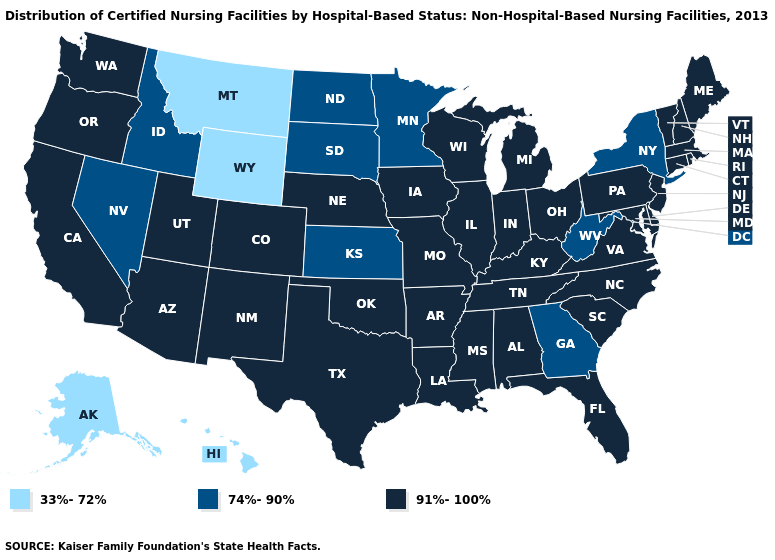Does Iowa have the highest value in the USA?
Be succinct. Yes. What is the lowest value in the Northeast?
Keep it brief. 74%-90%. What is the highest value in states that border Wisconsin?
Quick response, please. 91%-100%. Among the states that border Pennsylvania , which have the lowest value?
Answer briefly. New York, West Virginia. What is the value of New York?
Write a very short answer. 74%-90%. Among the states that border Montana , does Wyoming have the lowest value?
Keep it brief. Yes. Among the states that border Wisconsin , which have the lowest value?
Write a very short answer. Minnesota. Name the states that have a value in the range 91%-100%?
Write a very short answer. Alabama, Arizona, Arkansas, California, Colorado, Connecticut, Delaware, Florida, Illinois, Indiana, Iowa, Kentucky, Louisiana, Maine, Maryland, Massachusetts, Michigan, Mississippi, Missouri, Nebraska, New Hampshire, New Jersey, New Mexico, North Carolina, Ohio, Oklahoma, Oregon, Pennsylvania, Rhode Island, South Carolina, Tennessee, Texas, Utah, Vermont, Virginia, Washington, Wisconsin. Name the states that have a value in the range 74%-90%?
Quick response, please. Georgia, Idaho, Kansas, Minnesota, Nevada, New York, North Dakota, South Dakota, West Virginia. Which states have the highest value in the USA?
Give a very brief answer. Alabama, Arizona, Arkansas, California, Colorado, Connecticut, Delaware, Florida, Illinois, Indiana, Iowa, Kentucky, Louisiana, Maine, Maryland, Massachusetts, Michigan, Mississippi, Missouri, Nebraska, New Hampshire, New Jersey, New Mexico, North Carolina, Ohio, Oklahoma, Oregon, Pennsylvania, Rhode Island, South Carolina, Tennessee, Texas, Utah, Vermont, Virginia, Washington, Wisconsin. Does Montana have the lowest value in the USA?
Concise answer only. Yes. Name the states that have a value in the range 74%-90%?
Concise answer only. Georgia, Idaho, Kansas, Minnesota, Nevada, New York, North Dakota, South Dakota, West Virginia. What is the value of Louisiana?
Keep it brief. 91%-100%. Name the states that have a value in the range 91%-100%?
Answer briefly. Alabama, Arizona, Arkansas, California, Colorado, Connecticut, Delaware, Florida, Illinois, Indiana, Iowa, Kentucky, Louisiana, Maine, Maryland, Massachusetts, Michigan, Mississippi, Missouri, Nebraska, New Hampshire, New Jersey, New Mexico, North Carolina, Ohio, Oklahoma, Oregon, Pennsylvania, Rhode Island, South Carolina, Tennessee, Texas, Utah, Vermont, Virginia, Washington, Wisconsin. What is the value of Alaska?
Concise answer only. 33%-72%. 